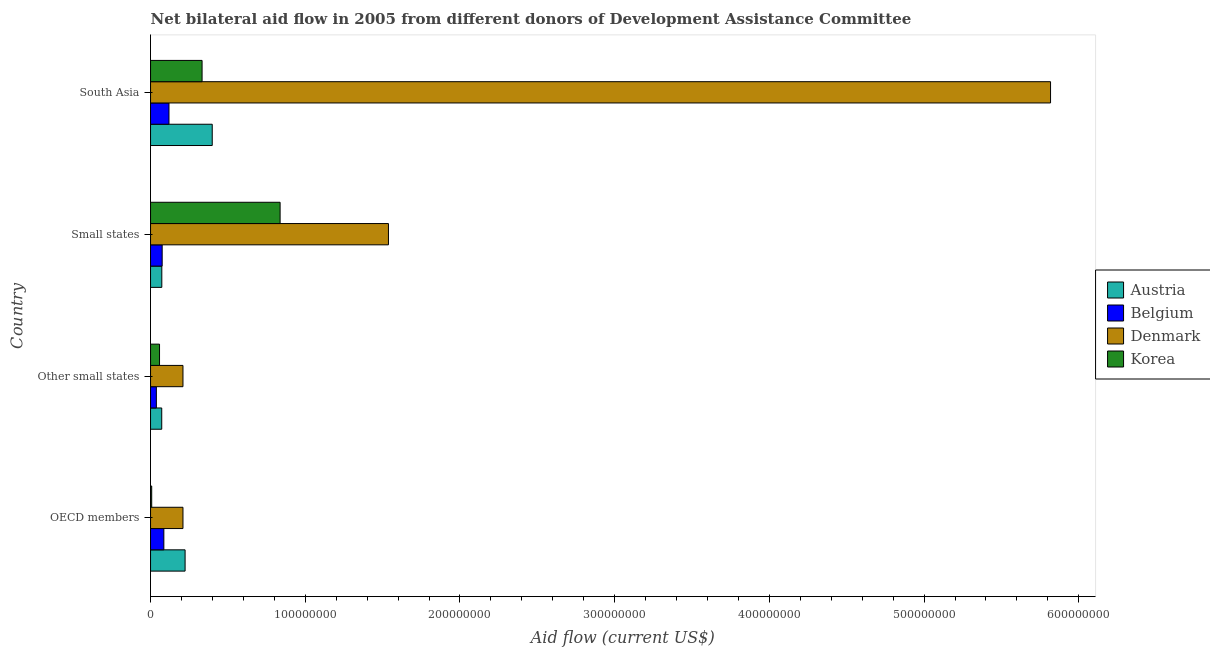Are the number of bars per tick equal to the number of legend labels?
Your response must be concise. Yes. Are the number of bars on each tick of the Y-axis equal?
Make the answer very short. Yes. What is the label of the 2nd group of bars from the top?
Make the answer very short. Small states. In how many cases, is the number of bars for a given country not equal to the number of legend labels?
Ensure brevity in your answer.  0. What is the amount of aid given by korea in Other small states?
Your answer should be very brief. 5.81e+06. Across all countries, what is the maximum amount of aid given by austria?
Provide a succinct answer. 3.99e+07. Across all countries, what is the minimum amount of aid given by austria?
Your answer should be compact. 7.24e+06. In which country was the amount of aid given by belgium maximum?
Offer a very short reply. South Asia. What is the total amount of aid given by belgium in the graph?
Your answer should be compact. 3.18e+07. What is the difference between the amount of aid given by korea in OECD members and that in South Asia?
Give a very brief answer. -3.26e+07. What is the difference between the amount of aid given by belgium in South Asia and the amount of aid given by korea in Small states?
Give a very brief answer. -7.18e+07. What is the average amount of aid given by austria per country?
Give a very brief answer. 1.92e+07. What is the difference between the amount of aid given by korea and amount of aid given by denmark in Other small states?
Your response must be concise. -1.52e+07. In how many countries, is the amount of aid given by denmark greater than 240000000 US$?
Provide a succinct answer. 1. What is the difference between the highest and the second highest amount of aid given by korea?
Offer a terse response. 5.04e+07. What is the difference between the highest and the lowest amount of aid given by austria?
Ensure brevity in your answer.  3.26e+07. In how many countries, is the amount of aid given by belgium greater than the average amount of aid given by belgium taken over all countries?
Give a very brief answer. 2. Is the sum of the amount of aid given by korea in Other small states and South Asia greater than the maximum amount of aid given by austria across all countries?
Keep it short and to the point. No. Is it the case that in every country, the sum of the amount of aid given by korea and amount of aid given by belgium is greater than the sum of amount of aid given by denmark and amount of aid given by austria?
Your response must be concise. No. What does the 1st bar from the bottom in Small states represents?
Your answer should be very brief. Austria. How many bars are there?
Provide a succinct answer. 16. What is the difference between two consecutive major ticks on the X-axis?
Keep it short and to the point. 1.00e+08. Does the graph contain grids?
Provide a short and direct response. No. Where does the legend appear in the graph?
Provide a short and direct response. Center right. How many legend labels are there?
Offer a very short reply. 4. What is the title of the graph?
Make the answer very short. Net bilateral aid flow in 2005 from different donors of Development Assistance Committee. Does "Structural Policies" appear as one of the legend labels in the graph?
Provide a succinct answer. No. What is the label or title of the X-axis?
Offer a very short reply. Aid flow (current US$). What is the label or title of the Y-axis?
Make the answer very short. Country. What is the Aid flow (current US$) in Austria in OECD members?
Provide a succinct answer. 2.23e+07. What is the Aid flow (current US$) in Belgium in OECD members?
Ensure brevity in your answer.  8.60e+06. What is the Aid flow (current US$) of Denmark in OECD members?
Keep it short and to the point. 2.10e+07. What is the Aid flow (current US$) of Korea in OECD members?
Your answer should be compact. 7.50e+05. What is the Aid flow (current US$) in Austria in Other small states?
Your answer should be very brief. 7.24e+06. What is the Aid flow (current US$) in Belgium in Other small states?
Make the answer very short. 3.76e+06. What is the Aid flow (current US$) of Denmark in Other small states?
Make the answer very short. 2.10e+07. What is the Aid flow (current US$) in Korea in Other small states?
Your answer should be compact. 5.81e+06. What is the Aid flow (current US$) of Austria in Small states?
Provide a succinct answer. 7.29e+06. What is the Aid flow (current US$) of Belgium in Small states?
Offer a terse response. 7.52e+06. What is the Aid flow (current US$) in Denmark in Small states?
Your answer should be compact. 1.54e+08. What is the Aid flow (current US$) of Korea in Small states?
Make the answer very short. 8.38e+07. What is the Aid flow (current US$) of Austria in South Asia?
Your answer should be compact. 3.99e+07. What is the Aid flow (current US$) of Belgium in South Asia?
Ensure brevity in your answer.  1.19e+07. What is the Aid flow (current US$) of Denmark in South Asia?
Keep it short and to the point. 5.82e+08. What is the Aid flow (current US$) in Korea in South Asia?
Ensure brevity in your answer.  3.33e+07. Across all countries, what is the maximum Aid flow (current US$) in Austria?
Make the answer very short. 3.99e+07. Across all countries, what is the maximum Aid flow (current US$) in Belgium?
Provide a succinct answer. 1.19e+07. Across all countries, what is the maximum Aid flow (current US$) in Denmark?
Offer a very short reply. 5.82e+08. Across all countries, what is the maximum Aid flow (current US$) of Korea?
Provide a short and direct response. 8.38e+07. Across all countries, what is the minimum Aid flow (current US$) in Austria?
Your answer should be compact. 7.24e+06. Across all countries, what is the minimum Aid flow (current US$) of Belgium?
Provide a succinct answer. 3.76e+06. Across all countries, what is the minimum Aid flow (current US$) in Denmark?
Your answer should be compact. 2.10e+07. Across all countries, what is the minimum Aid flow (current US$) of Korea?
Make the answer very short. 7.50e+05. What is the total Aid flow (current US$) of Austria in the graph?
Keep it short and to the point. 7.68e+07. What is the total Aid flow (current US$) of Belgium in the graph?
Keep it short and to the point. 3.18e+07. What is the total Aid flow (current US$) of Denmark in the graph?
Make the answer very short. 7.77e+08. What is the total Aid flow (current US$) in Korea in the graph?
Your response must be concise. 1.24e+08. What is the difference between the Aid flow (current US$) of Austria in OECD members and that in Other small states?
Offer a terse response. 1.51e+07. What is the difference between the Aid flow (current US$) of Belgium in OECD members and that in Other small states?
Offer a very short reply. 4.84e+06. What is the difference between the Aid flow (current US$) in Denmark in OECD members and that in Other small states?
Give a very brief answer. 0. What is the difference between the Aid flow (current US$) of Korea in OECD members and that in Other small states?
Your answer should be very brief. -5.06e+06. What is the difference between the Aid flow (current US$) in Austria in OECD members and that in Small states?
Your answer should be compact. 1.50e+07. What is the difference between the Aid flow (current US$) of Belgium in OECD members and that in Small states?
Give a very brief answer. 1.08e+06. What is the difference between the Aid flow (current US$) of Denmark in OECD members and that in Small states?
Offer a terse response. -1.33e+08. What is the difference between the Aid flow (current US$) in Korea in OECD members and that in Small states?
Your answer should be very brief. -8.30e+07. What is the difference between the Aid flow (current US$) in Austria in OECD members and that in South Asia?
Keep it short and to the point. -1.75e+07. What is the difference between the Aid flow (current US$) of Belgium in OECD members and that in South Asia?
Give a very brief answer. -3.32e+06. What is the difference between the Aid flow (current US$) of Denmark in OECD members and that in South Asia?
Offer a very short reply. -5.61e+08. What is the difference between the Aid flow (current US$) of Korea in OECD members and that in South Asia?
Provide a short and direct response. -3.26e+07. What is the difference between the Aid flow (current US$) of Austria in Other small states and that in Small states?
Make the answer very short. -5.00e+04. What is the difference between the Aid flow (current US$) of Belgium in Other small states and that in Small states?
Offer a terse response. -3.76e+06. What is the difference between the Aid flow (current US$) of Denmark in Other small states and that in Small states?
Your answer should be very brief. -1.33e+08. What is the difference between the Aid flow (current US$) of Korea in Other small states and that in Small states?
Make the answer very short. -7.79e+07. What is the difference between the Aid flow (current US$) of Austria in Other small states and that in South Asia?
Provide a short and direct response. -3.26e+07. What is the difference between the Aid flow (current US$) in Belgium in Other small states and that in South Asia?
Offer a very short reply. -8.16e+06. What is the difference between the Aid flow (current US$) of Denmark in Other small states and that in South Asia?
Make the answer very short. -5.61e+08. What is the difference between the Aid flow (current US$) in Korea in Other small states and that in South Asia?
Provide a succinct answer. -2.75e+07. What is the difference between the Aid flow (current US$) in Austria in Small states and that in South Asia?
Your answer should be compact. -3.26e+07. What is the difference between the Aid flow (current US$) in Belgium in Small states and that in South Asia?
Keep it short and to the point. -4.40e+06. What is the difference between the Aid flow (current US$) of Denmark in Small states and that in South Asia?
Provide a succinct answer. -4.28e+08. What is the difference between the Aid flow (current US$) of Korea in Small states and that in South Asia?
Your answer should be compact. 5.04e+07. What is the difference between the Aid flow (current US$) in Austria in OECD members and the Aid flow (current US$) in Belgium in Other small states?
Offer a very short reply. 1.86e+07. What is the difference between the Aid flow (current US$) of Austria in OECD members and the Aid flow (current US$) of Denmark in Other small states?
Keep it short and to the point. 1.38e+06. What is the difference between the Aid flow (current US$) in Austria in OECD members and the Aid flow (current US$) in Korea in Other small states?
Your answer should be very brief. 1.65e+07. What is the difference between the Aid flow (current US$) of Belgium in OECD members and the Aid flow (current US$) of Denmark in Other small states?
Offer a very short reply. -1.24e+07. What is the difference between the Aid flow (current US$) in Belgium in OECD members and the Aid flow (current US$) in Korea in Other small states?
Ensure brevity in your answer.  2.79e+06. What is the difference between the Aid flow (current US$) in Denmark in OECD members and the Aid flow (current US$) in Korea in Other small states?
Ensure brevity in your answer.  1.52e+07. What is the difference between the Aid flow (current US$) of Austria in OECD members and the Aid flow (current US$) of Belgium in Small states?
Offer a terse response. 1.48e+07. What is the difference between the Aid flow (current US$) in Austria in OECD members and the Aid flow (current US$) in Denmark in Small states?
Your response must be concise. -1.31e+08. What is the difference between the Aid flow (current US$) of Austria in OECD members and the Aid flow (current US$) of Korea in Small states?
Make the answer very short. -6.14e+07. What is the difference between the Aid flow (current US$) in Belgium in OECD members and the Aid flow (current US$) in Denmark in Small states?
Your answer should be very brief. -1.45e+08. What is the difference between the Aid flow (current US$) in Belgium in OECD members and the Aid flow (current US$) in Korea in Small states?
Make the answer very short. -7.52e+07. What is the difference between the Aid flow (current US$) of Denmark in OECD members and the Aid flow (current US$) of Korea in Small states?
Provide a succinct answer. -6.28e+07. What is the difference between the Aid flow (current US$) in Austria in OECD members and the Aid flow (current US$) in Belgium in South Asia?
Offer a very short reply. 1.04e+07. What is the difference between the Aid flow (current US$) of Austria in OECD members and the Aid flow (current US$) of Denmark in South Asia?
Give a very brief answer. -5.59e+08. What is the difference between the Aid flow (current US$) of Austria in OECD members and the Aid flow (current US$) of Korea in South Asia?
Give a very brief answer. -1.10e+07. What is the difference between the Aid flow (current US$) in Belgium in OECD members and the Aid flow (current US$) in Denmark in South Asia?
Keep it short and to the point. -5.73e+08. What is the difference between the Aid flow (current US$) of Belgium in OECD members and the Aid flow (current US$) of Korea in South Asia?
Keep it short and to the point. -2.47e+07. What is the difference between the Aid flow (current US$) of Denmark in OECD members and the Aid flow (current US$) of Korea in South Asia?
Offer a terse response. -1.24e+07. What is the difference between the Aid flow (current US$) of Austria in Other small states and the Aid flow (current US$) of Belgium in Small states?
Keep it short and to the point. -2.80e+05. What is the difference between the Aid flow (current US$) in Austria in Other small states and the Aid flow (current US$) in Denmark in Small states?
Ensure brevity in your answer.  -1.47e+08. What is the difference between the Aid flow (current US$) of Austria in Other small states and the Aid flow (current US$) of Korea in Small states?
Ensure brevity in your answer.  -7.65e+07. What is the difference between the Aid flow (current US$) of Belgium in Other small states and the Aid flow (current US$) of Denmark in Small states?
Provide a short and direct response. -1.50e+08. What is the difference between the Aid flow (current US$) of Belgium in Other small states and the Aid flow (current US$) of Korea in Small states?
Your response must be concise. -8.00e+07. What is the difference between the Aid flow (current US$) in Denmark in Other small states and the Aid flow (current US$) in Korea in Small states?
Offer a very short reply. -6.28e+07. What is the difference between the Aid flow (current US$) in Austria in Other small states and the Aid flow (current US$) in Belgium in South Asia?
Provide a succinct answer. -4.68e+06. What is the difference between the Aid flow (current US$) of Austria in Other small states and the Aid flow (current US$) of Denmark in South Asia?
Your answer should be compact. -5.75e+08. What is the difference between the Aid flow (current US$) in Austria in Other small states and the Aid flow (current US$) in Korea in South Asia?
Offer a very short reply. -2.61e+07. What is the difference between the Aid flow (current US$) in Belgium in Other small states and the Aid flow (current US$) in Denmark in South Asia?
Ensure brevity in your answer.  -5.78e+08. What is the difference between the Aid flow (current US$) of Belgium in Other small states and the Aid flow (current US$) of Korea in South Asia?
Keep it short and to the point. -2.96e+07. What is the difference between the Aid flow (current US$) in Denmark in Other small states and the Aid flow (current US$) in Korea in South Asia?
Provide a succinct answer. -1.24e+07. What is the difference between the Aid flow (current US$) in Austria in Small states and the Aid flow (current US$) in Belgium in South Asia?
Provide a short and direct response. -4.63e+06. What is the difference between the Aid flow (current US$) of Austria in Small states and the Aid flow (current US$) of Denmark in South Asia?
Offer a terse response. -5.74e+08. What is the difference between the Aid flow (current US$) of Austria in Small states and the Aid flow (current US$) of Korea in South Asia?
Provide a short and direct response. -2.60e+07. What is the difference between the Aid flow (current US$) in Belgium in Small states and the Aid flow (current US$) in Denmark in South Asia?
Make the answer very short. -5.74e+08. What is the difference between the Aid flow (current US$) of Belgium in Small states and the Aid flow (current US$) of Korea in South Asia?
Your answer should be very brief. -2.58e+07. What is the difference between the Aid flow (current US$) of Denmark in Small states and the Aid flow (current US$) of Korea in South Asia?
Your answer should be very brief. 1.20e+08. What is the average Aid flow (current US$) of Austria per country?
Make the answer very short. 1.92e+07. What is the average Aid flow (current US$) of Belgium per country?
Make the answer very short. 7.95e+06. What is the average Aid flow (current US$) in Denmark per country?
Offer a very short reply. 1.94e+08. What is the average Aid flow (current US$) in Korea per country?
Your answer should be very brief. 3.09e+07. What is the difference between the Aid flow (current US$) of Austria and Aid flow (current US$) of Belgium in OECD members?
Keep it short and to the point. 1.37e+07. What is the difference between the Aid flow (current US$) in Austria and Aid flow (current US$) in Denmark in OECD members?
Provide a short and direct response. 1.38e+06. What is the difference between the Aid flow (current US$) of Austria and Aid flow (current US$) of Korea in OECD members?
Your answer should be very brief. 2.16e+07. What is the difference between the Aid flow (current US$) in Belgium and Aid flow (current US$) in Denmark in OECD members?
Keep it short and to the point. -1.24e+07. What is the difference between the Aid flow (current US$) in Belgium and Aid flow (current US$) in Korea in OECD members?
Provide a succinct answer. 7.85e+06. What is the difference between the Aid flow (current US$) of Denmark and Aid flow (current US$) of Korea in OECD members?
Keep it short and to the point. 2.02e+07. What is the difference between the Aid flow (current US$) of Austria and Aid flow (current US$) of Belgium in Other small states?
Give a very brief answer. 3.48e+06. What is the difference between the Aid flow (current US$) in Austria and Aid flow (current US$) in Denmark in Other small states?
Your answer should be very brief. -1.37e+07. What is the difference between the Aid flow (current US$) of Austria and Aid flow (current US$) of Korea in Other small states?
Offer a terse response. 1.43e+06. What is the difference between the Aid flow (current US$) of Belgium and Aid flow (current US$) of Denmark in Other small states?
Offer a terse response. -1.72e+07. What is the difference between the Aid flow (current US$) in Belgium and Aid flow (current US$) in Korea in Other small states?
Give a very brief answer. -2.05e+06. What is the difference between the Aid flow (current US$) of Denmark and Aid flow (current US$) of Korea in Other small states?
Keep it short and to the point. 1.52e+07. What is the difference between the Aid flow (current US$) of Austria and Aid flow (current US$) of Belgium in Small states?
Offer a terse response. -2.30e+05. What is the difference between the Aid flow (current US$) in Austria and Aid flow (current US$) in Denmark in Small states?
Your response must be concise. -1.46e+08. What is the difference between the Aid flow (current US$) of Austria and Aid flow (current US$) of Korea in Small states?
Offer a terse response. -7.65e+07. What is the difference between the Aid flow (current US$) in Belgium and Aid flow (current US$) in Denmark in Small states?
Provide a short and direct response. -1.46e+08. What is the difference between the Aid flow (current US$) in Belgium and Aid flow (current US$) in Korea in Small states?
Offer a terse response. -7.62e+07. What is the difference between the Aid flow (current US$) in Denmark and Aid flow (current US$) in Korea in Small states?
Provide a short and direct response. 7.00e+07. What is the difference between the Aid flow (current US$) in Austria and Aid flow (current US$) in Belgium in South Asia?
Provide a short and direct response. 2.80e+07. What is the difference between the Aid flow (current US$) of Austria and Aid flow (current US$) of Denmark in South Asia?
Ensure brevity in your answer.  -5.42e+08. What is the difference between the Aid flow (current US$) of Austria and Aid flow (current US$) of Korea in South Asia?
Your response must be concise. 6.57e+06. What is the difference between the Aid flow (current US$) in Belgium and Aid flow (current US$) in Denmark in South Asia?
Offer a very short reply. -5.70e+08. What is the difference between the Aid flow (current US$) of Belgium and Aid flow (current US$) of Korea in South Asia?
Keep it short and to the point. -2.14e+07. What is the difference between the Aid flow (current US$) in Denmark and Aid flow (current US$) in Korea in South Asia?
Your answer should be very brief. 5.48e+08. What is the ratio of the Aid flow (current US$) in Austria in OECD members to that in Other small states?
Your answer should be compact. 3.09. What is the ratio of the Aid flow (current US$) in Belgium in OECD members to that in Other small states?
Keep it short and to the point. 2.29. What is the ratio of the Aid flow (current US$) of Denmark in OECD members to that in Other small states?
Your answer should be compact. 1. What is the ratio of the Aid flow (current US$) in Korea in OECD members to that in Other small states?
Provide a succinct answer. 0.13. What is the ratio of the Aid flow (current US$) of Austria in OECD members to that in Small states?
Your answer should be compact. 3.06. What is the ratio of the Aid flow (current US$) of Belgium in OECD members to that in Small states?
Your response must be concise. 1.14. What is the ratio of the Aid flow (current US$) of Denmark in OECD members to that in Small states?
Your answer should be compact. 0.14. What is the ratio of the Aid flow (current US$) in Korea in OECD members to that in Small states?
Keep it short and to the point. 0.01. What is the ratio of the Aid flow (current US$) in Austria in OECD members to that in South Asia?
Provide a succinct answer. 0.56. What is the ratio of the Aid flow (current US$) in Belgium in OECD members to that in South Asia?
Provide a short and direct response. 0.72. What is the ratio of the Aid flow (current US$) of Denmark in OECD members to that in South Asia?
Your answer should be very brief. 0.04. What is the ratio of the Aid flow (current US$) in Korea in OECD members to that in South Asia?
Offer a very short reply. 0.02. What is the ratio of the Aid flow (current US$) of Austria in Other small states to that in Small states?
Your response must be concise. 0.99. What is the ratio of the Aid flow (current US$) in Denmark in Other small states to that in Small states?
Provide a succinct answer. 0.14. What is the ratio of the Aid flow (current US$) in Korea in Other small states to that in Small states?
Your answer should be compact. 0.07. What is the ratio of the Aid flow (current US$) in Austria in Other small states to that in South Asia?
Your answer should be compact. 0.18. What is the ratio of the Aid flow (current US$) of Belgium in Other small states to that in South Asia?
Provide a succinct answer. 0.32. What is the ratio of the Aid flow (current US$) of Denmark in Other small states to that in South Asia?
Your answer should be compact. 0.04. What is the ratio of the Aid flow (current US$) of Korea in Other small states to that in South Asia?
Provide a succinct answer. 0.17. What is the ratio of the Aid flow (current US$) of Austria in Small states to that in South Asia?
Offer a terse response. 0.18. What is the ratio of the Aid flow (current US$) of Belgium in Small states to that in South Asia?
Provide a short and direct response. 0.63. What is the ratio of the Aid flow (current US$) of Denmark in Small states to that in South Asia?
Keep it short and to the point. 0.26. What is the ratio of the Aid flow (current US$) of Korea in Small states to that in South Asia?
Keep it short and to the point. 2.51. What is the difference between the highest and the second highest Aid flow (current US$) in Austria?
Keep it short and to the point. 1.75e+07. What is the difference between the highest and the second highest Aid flow (current US$) of Belgium?
Make the answer very short. 3.32e+06. What is the difference between the highest and the second highest Aid flow (current US$) of Denmark?
Your answer should be compact. 4.28e+08. What is the difference between the highest and the second highest Aid flow (current US$) of Korea?
Provide a succinct answer. 5.04e+07. What is the difference between the highest and the lowest Aid flow (current US$) of Austria?
Your answer should be very brief. 3.26e+07. What is the difference between the highest and the lowest Aid flow (current US$) in Belgium?
Ensure brevity in your answer.  8.16e+06. What is the difference between the highest and the lowest Aid flow (current US$) in Denmark?
Provide a succinct answer. 5.61e+08. What is the difference between the highest and the lowest Aid flow (current US$) in Korea?
Offer a very short reply. 8.30e+07. 